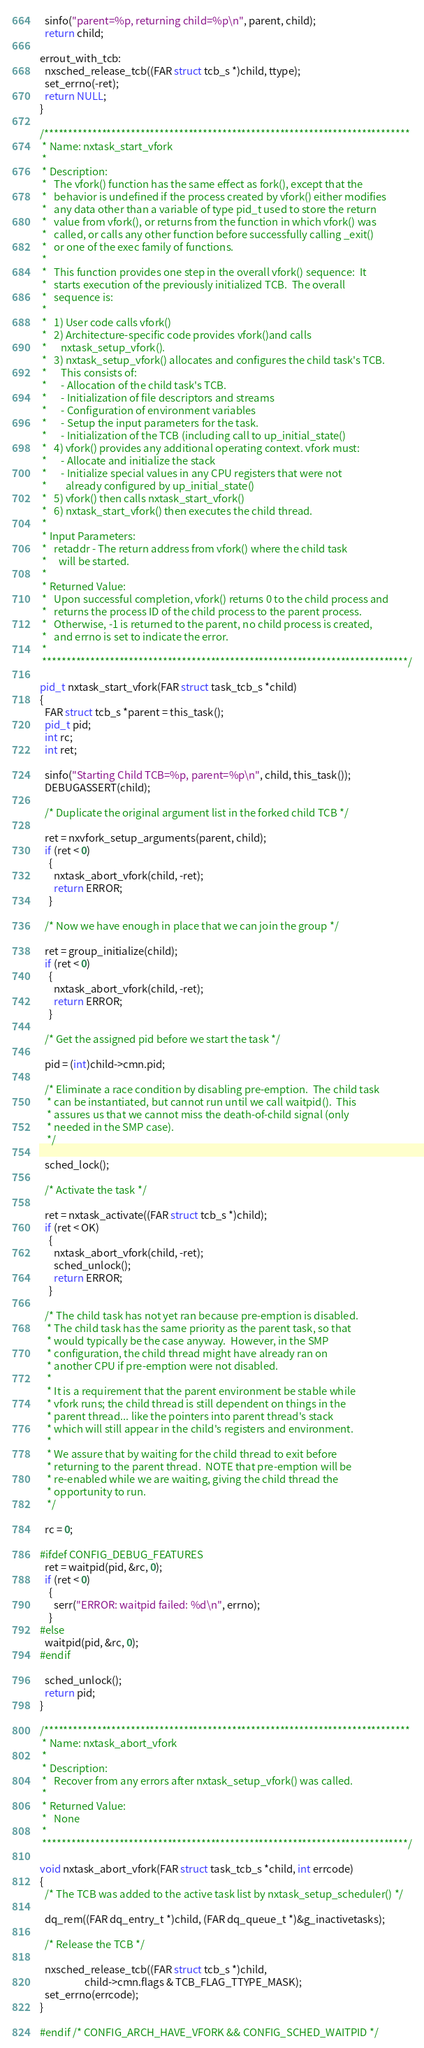Convert code to text. <code><loc_0><loc_0><loc_500><loc_500><_C_>
  sinfo("parent=%p, returning child=%p\n", parent, child);
  return child;

errout_with_tcb:
  nxsched_release_tcb((FAR struct tcb_s *)child, ttype);
  set_errno(-ret);
  return NULL;
}

/****************************************************************************
 * Name: nxtask_start_vfork
 *
 * Description:
 *   The vfork() function has the same effect as fork(), except that the
 *   behavior is undefined if the process created by vfork() either modifies
 *   any data other than a variable of type pid_t used to store the return
 *   value from vfork(), or returns from the function in which vfork() was
 *   called, or calls any other function before successfully calling _exit()
 *   or one of the exec family of functions.
 *
 *   This function provides one step in the overall vfork() sequence:  It
 *   starts execution of the previously initialized TCB.  The overall
 *   sequence is:
 *
 *   1) User code calls vfork()
 *   2) Architecture-specific code provides vfork()and calls
 *      nxtask_setup_vfork().
 *   3) nxtask_setup_vfork() allocates and configures the child task's TCB.
 *      This consists of:
 *      - Allocation of the child task's TCB.
 *      - Initialization of file descriptors and streams
 *      - Configuration of environment variables
 *      - Setup the input parameters for the task.
 *      - Initialization of the TCB (including call to up_initial_state()
 *   4) vfork() provides any additional operating context. vfork must:
 *      - Allocate and initialize the stack
 *      - Initialize special values in any CPU registers that were not
 *        already configured by up_initial_state()
 *   5) vfork() then calls nxtask_start_vfork()
 *   6) nxtask_start_vfork() then executes the child thread.
 *
 * Input Parameters:
 *   retaddr - The return address from vfork() where the child task
 *     will be started.
 *
 * Returned Value:
 *   Upon successful completion, vfork() returns 0 to the child process and
 *   returns the process ID of the child process to the parent process.
 *   Otherwise, -1 is returned to the parent, no child process is created,
 *   and errno is set to indicate the error.
 *
 ****************************************************************************/

pid_t nxtask_start_vfork(FAR struct task_tcb_s *child)
{
  FAR struct tcb_s *parent = this_task();
  pid_t pid;
  int rc;
  int ret;

  sinfo("Starting Child TCB=%p, parent=%p\n", child, this_task());
  DEBUGASSERT(child);

  /* Duplicate the original argument list in the forked child TCB */

  ret = nxvfork_setup_arguments(parent, child);
  if (ret < 0)
    {
      nxtask_abort_vfork(child, -ret);
      return ERROR;
    }

  /* Now we have enough in place that we can join the group */

  ret = group_initialize(child);
  if (ret < 0)
    {
      nxtask_abort_vfork(child, -ret);
      return ERROR;
    }

  /* Get the assigned pid before we start the task */

  pid = (int)child->cmn.pid;

  /* Eliminate a race condition by disabling pre-emption.  The child task
   * can be instantiated, but cannot run until we call waitpid().  This
   * assures us that we cannot miss the death-of-child signal (only
   * needed in the SMP case).
   */

  sched_lock();

  /* Activate the task */

  ret = nxtask_activate((FAR struct tcb_s *)child);
  if (ret < OK)
    {
      nxtask_abort_vfork(child, -ret);
      sched_unlock();
      return ERROR;
    }

  /* The child task has not yet ran because pre-emption is disabled.
   * The child task has the same priority as the parent task, so that
   * would typically be the case anyway.  However, in the SMP
   * configuration, the child thread might have already ran on
   * another CPU if pre-emption were not disabled.
   *
   * It is a requirement that the parent environment be stable while
   * vfork runs; the child thread is still dependent on things in the
   * parent thread... like the pointers into parent thread's stack
   * which will still appear in the child's registers and environment.
   *
   * We assure that by waiting for the child thread to exit before
   * returning to the parent thread.  NOTE that pre-emption will be
   * re-enabled while we are waiting, giving the child thread the
   * opportunity to run.
   */

  rc = 0;

#ifdef CONFIG_DEBUG_FEATURES
  ret = waitpid(pid, &rc, 0);
  if (ret < 0)
    {
      serr("ERROR: waitpid failed: %d\n", errno);
    }
#else
  waitpid(pid, &rc, 0);
#endif

  sched_unlock();
  return pid;
}

/****************************************************************************
 * Name: nxtask_abort_vfork
 *
 * Description:
 *   Recover from any errors after nxtask_setup_vfork() was called.
 *
 * Returned Value:
 *   None
 *
 ****************************************************************************/

void nxtask_abort_vfork(FAR struct task_tcb_s *child, int errcode)
{
  /* The TCB was added to the active task list by nxtask_setup_scheduler() */

  dq_rem((FAR dq_entry_t *)child, (FAR dq_queue_t *)&g_inactivetasks);

  /* Release the TCB */

  nxsched_release_tcb((FAR struct tcb_s *)child,
                   child->cmn.flags & TCB_FLAG_TTYPE_MASK);
  set_errno(errcode);
}

#endif /* CONFIG_ARCH_HAVE_VFORK && CONFIG_SCHED_WAITPID */
</code> 